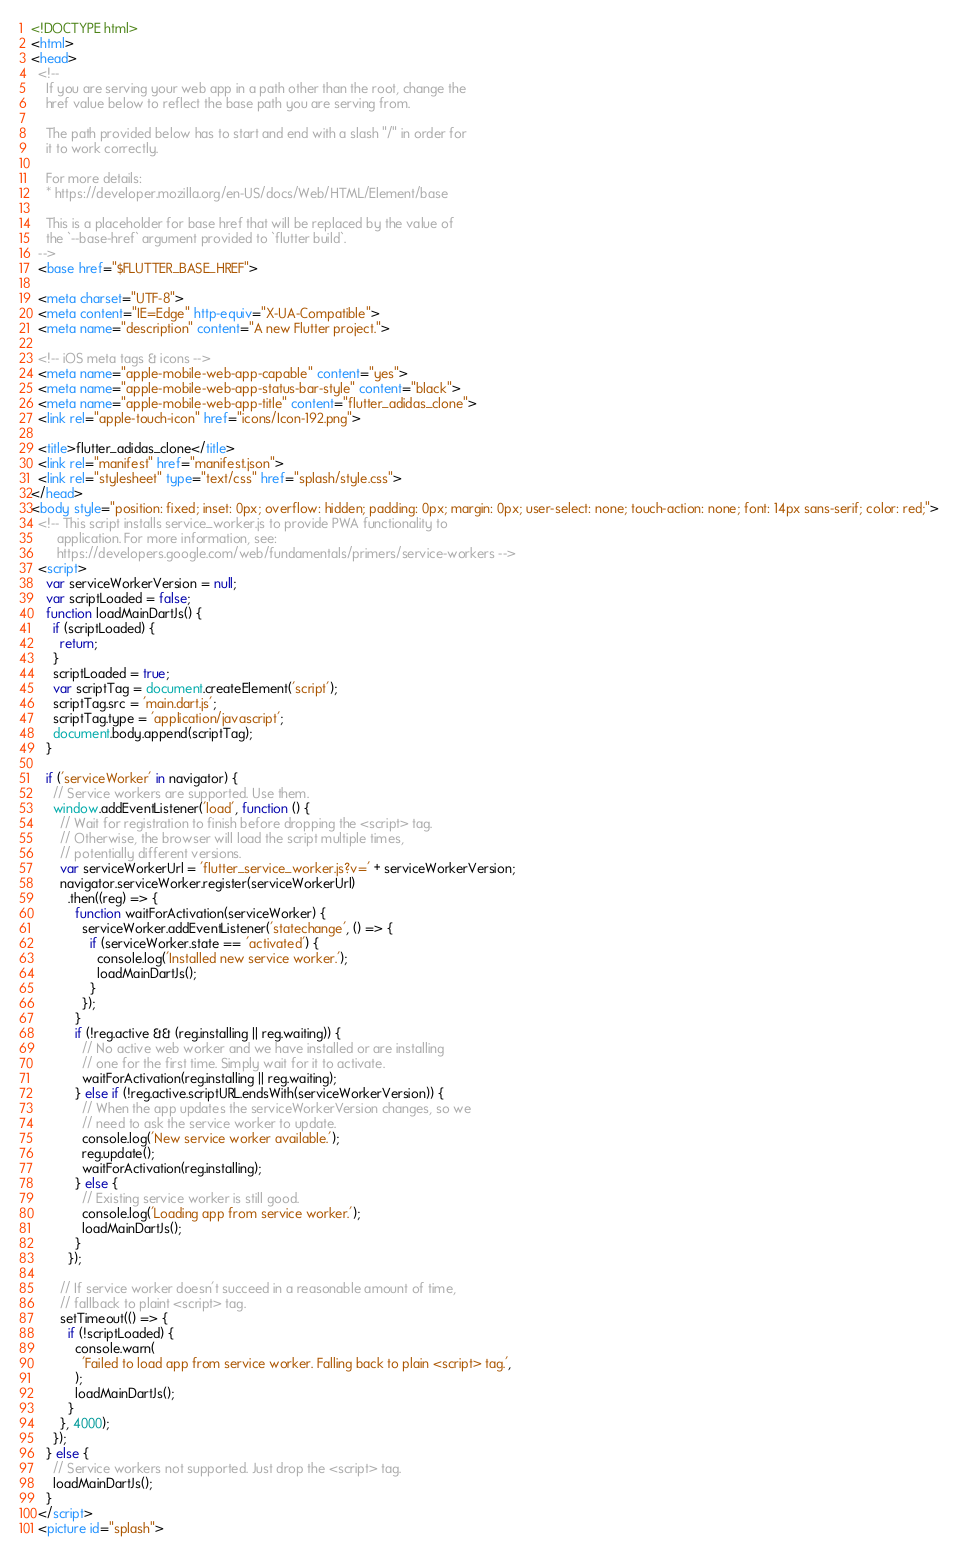<code> <loc_0><loc_0><loc_500><loc_500><_HTML_><!DOCTYPE html>
<html>
<head>
  <!--
    If you are serving your web app in a path other than the root, change the
    href value below to reflect the base path you are serving from.

    The path provided below has to start and end with a slash "/" in order for
    it to work correctly.

    For more details:
    * https://developer.mozilla.org/en-US/docs/Web/HTML/Element/base

    This is a placeholder for base href that will be replaced by the value of
    the `--base-href` argument provided to `flutter build`.
  -->
  <base href="$FLUTTER_BASE_HREF">

  <meta charset="UTF-8">
  <meta content="IE=Edge" http-equiv="X-UA-Compatible">
  <meta name="description" content="A new Flutter project.">

  <!-- iOS meta tags & icons -->
  <meta name="apple-mobile-web-app-capable" content="yes">
  <meta name="apple-mobile-web-app-status-bar-style" content="black">
  <meta name="apple-mobile-web-app-title" content="flutter_adidas_clone">
  <link rel="apple-touch-icon" href="icons/Icon-192.png">

  <title>flutter_adidas_clone</title>
  <link rel="manifest" href="manifest.json">
  <link rel="stylesheet" type="text/css" href="splash/style.css">
</head>
<body style="position: fixed; inset: 0px; overflow: hidden; padding: 0px; margin: 0px; user-select: none; touch-action: none; font: 14px sans-serif; color: red;">
  <!-- This script installs service_worker.js to provide PWA functionality to
       application. For more information, see:
       https://developers.google.com/web/fundamentals/primers/service-workers -->
  <script>
    var serviceWorkerVersion = null;
    var scriptLoaded = false;
    function loadMainDartJs() {
      if (scriptLoaded) {
        return;
      }
      scriptLoaded = true;
      var scriptTag = document.createElement('script');
      scriptTag.src = 'main.dart.js';
      scriptTag.type = 'application/javascript';
      document.body.append(scriptTag);
    }

    if ('serviceWorker' in navigator) {
      // Service workers are supported. Use them.
      window.addEventListener('load', function () {
        // Wait for registration to finish before dropping the <script> tag.
        // Otherwise, the browser will load the script multiple times,
        // potentially different versions.
        var serviceWorkerUrl = 'flutter_service_worker.js?v=' + serviceWorkerVersion;
        navigator.serviceWorker.register(serviceWorkerUrl)
          .then((reg) => {
            function waitForActivation(serviceWorker) {
              serviceWorker.addEventListener('statechange', () => {
                if (serviceWorker.state == 'activated') {
                  console.log('Installed new service worker.');
                  loadMainDartJs();
                }
              });
            }
            if (!reg.active && (reg.installing || reg.waiting)) {
              // No active web worker and we have installed or are installing
              // one for the first time. Simply wait for it to activate.
              waitForActivation(reg.installing || reg.waiting);
            } else if (!reg.active.scriptURL.endsWith(serviceWorkerVersion)) {
              // When the app updates the serviceWorkerVersion changes, so we
              // need to ask the service worker to update.
              console.log('New service worker available.');
              reg.update();
              waitForActivation(reg.installing);
            } else {
              // Existing service worker is still good.
              console.log('Loading app from service worker.');
              loadMainDartJs();
            }
          });

        // If service worker doesn't succeed in a reasonable amount of time,
        // fallback to plaint <script> tag.
        setTimeout(() => {
          if (!scriptLoaded) {
            console.warn(
              'Failed to load app from service worker. Falling back to plain <script> tag.',
            );
            loadMainDartJs();
          }
        }, 4000);
      });
    } else {
      // Service workers not supported. Just drop the <script> tag.
      loadMainDartJs();
    }
  </script>
  <picture id="splash"></code> 